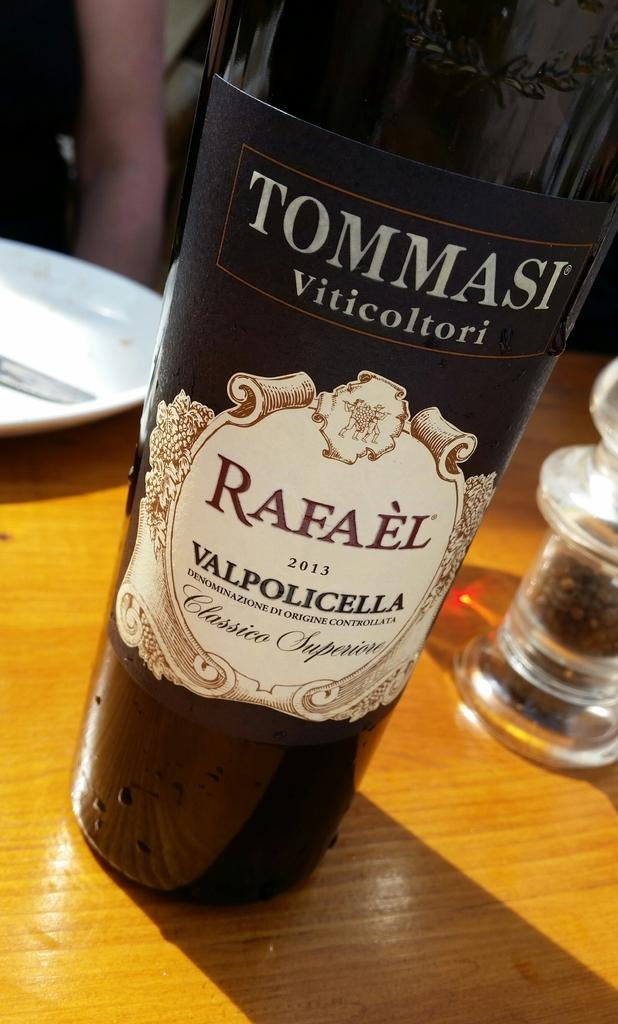<image>
Render a clear and concise summary of the photo. A wine bottle that says Ommasi Viticoltori on it. 